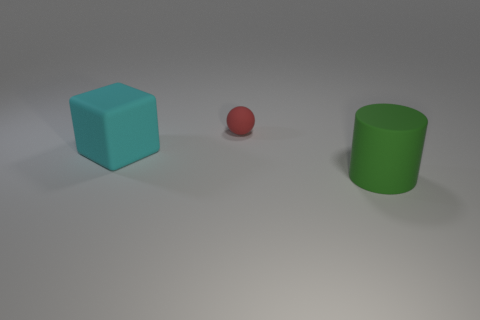What can you tell me about the lighting in this scene? The lighting in the scene is soft and diffused, casting gentle shadows on the floor from the objects. It seems to be coming from an overhead source, given the way shadows are directed. This type of lighting creates a calm atmosphere with no harsh contrasts. 